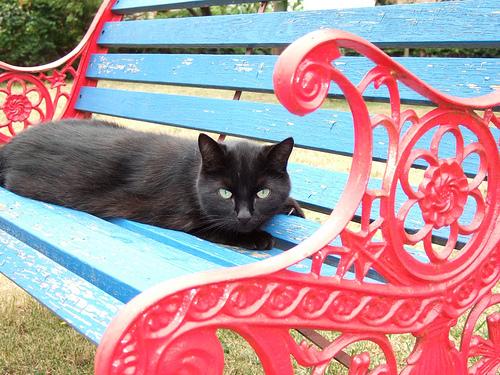What colors are the bench?
Quick response, please. Blue and red. Is this cat orange?
Quick response, please. No. Is this cat in attack mode or is he just sunning himself?
Keep it brief. Sunning. 